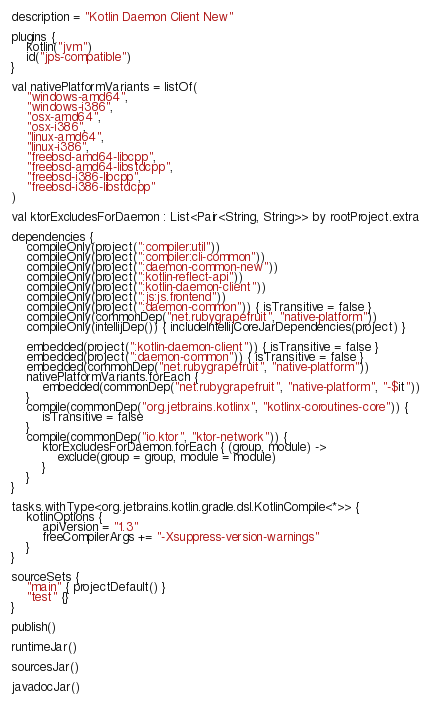Convert code to text. <code><loc_0><loc_0><loc_500><loc_500><_Kotlin_>description = "Kotlin Daemon Client New"

plugins {
    kotlin("jvm")
    id("jps-compatible")
}

val nativePlatformVariants = listOf(
    "windows-amd64",
    "windows-i386",
    "osx-amd64",
    "osx-i386",
    "linux-amd64",
    "linux-i386",
    "freebsd-amd64-libcpp",
    "freebsd-amd64-libstdcpp",
    "freebsd-i386-libcpp",
    "freebsd-i386-libstdcpp"
)

val ktorExcludesForDaemon : List<Pair<String, String>> by rootProject.extra

dependencies {
    compileOnly(project(":compiler:util"))
    compileOnly(project(":compiler:cli-common"))
    compileOnly(project(":daemon-common-new"))
    compileOnly(project(":kotlin-reflect-api"))
    compileOnly(project(":kotlin-daemon-client"))
    compileOnly(project(":js:js.frontend"))
    compileOnly(project(":daemon-common")) { isTransitive = false }
    compileOnly(commonDep("net.rubygrapefruit", "native-platform"))
    compileOnly(intellijDep()) { includeIntellijCoreJarDependencies(project) }

    embedded(project(":kotlin-daemon-client")) { isTransitive = false }
    embedded(project(":daemon-common")) { isTransitive = false }
    embedded(commonDep("net.rubygrapefruit", "native-platform"))
    nativePlatformVariants.forEach {
        embedded(commonDep("net.rubygrapefruit", "native-platform", "-$it"))
    }
    compile(commonDep("org.jetbrains.kotlinx", "kotlinx-coroutines-core")) {
        isTransitive = false
    }
    compile(commonDep("io.ktor", "ktor-network")) {
        ktorExcludesForDaemon.forEach { (group, module) ->
            exclude(group = group, module = module)
        }
    }
}

tasks.withType<org.jetbrains.kotlin.gradle.dsl.KotlinCompile<*>> {
    kotlinOptions {
        apiVersion = "1.3"
        freeCompilerArgs += "-Xsuppress-version-warnings"
    }
}

sourceSets {
    "main" { projectDefault() }
    "test" {}
}

publish()

runtimeJar()

sourcesJar()

javadocJar()
</code> 